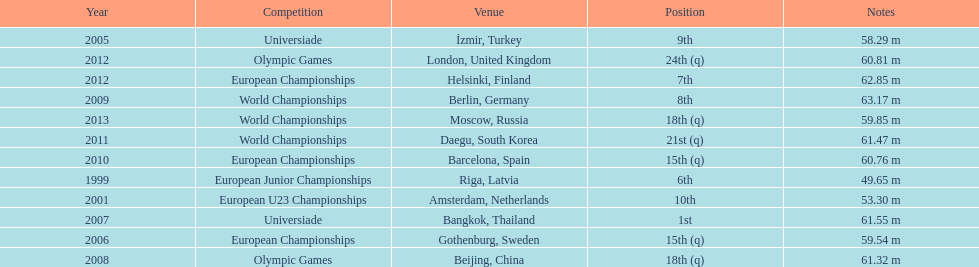Name two events in which mayer competed before he won the bangkok universiade. European Championships, Universiade. 